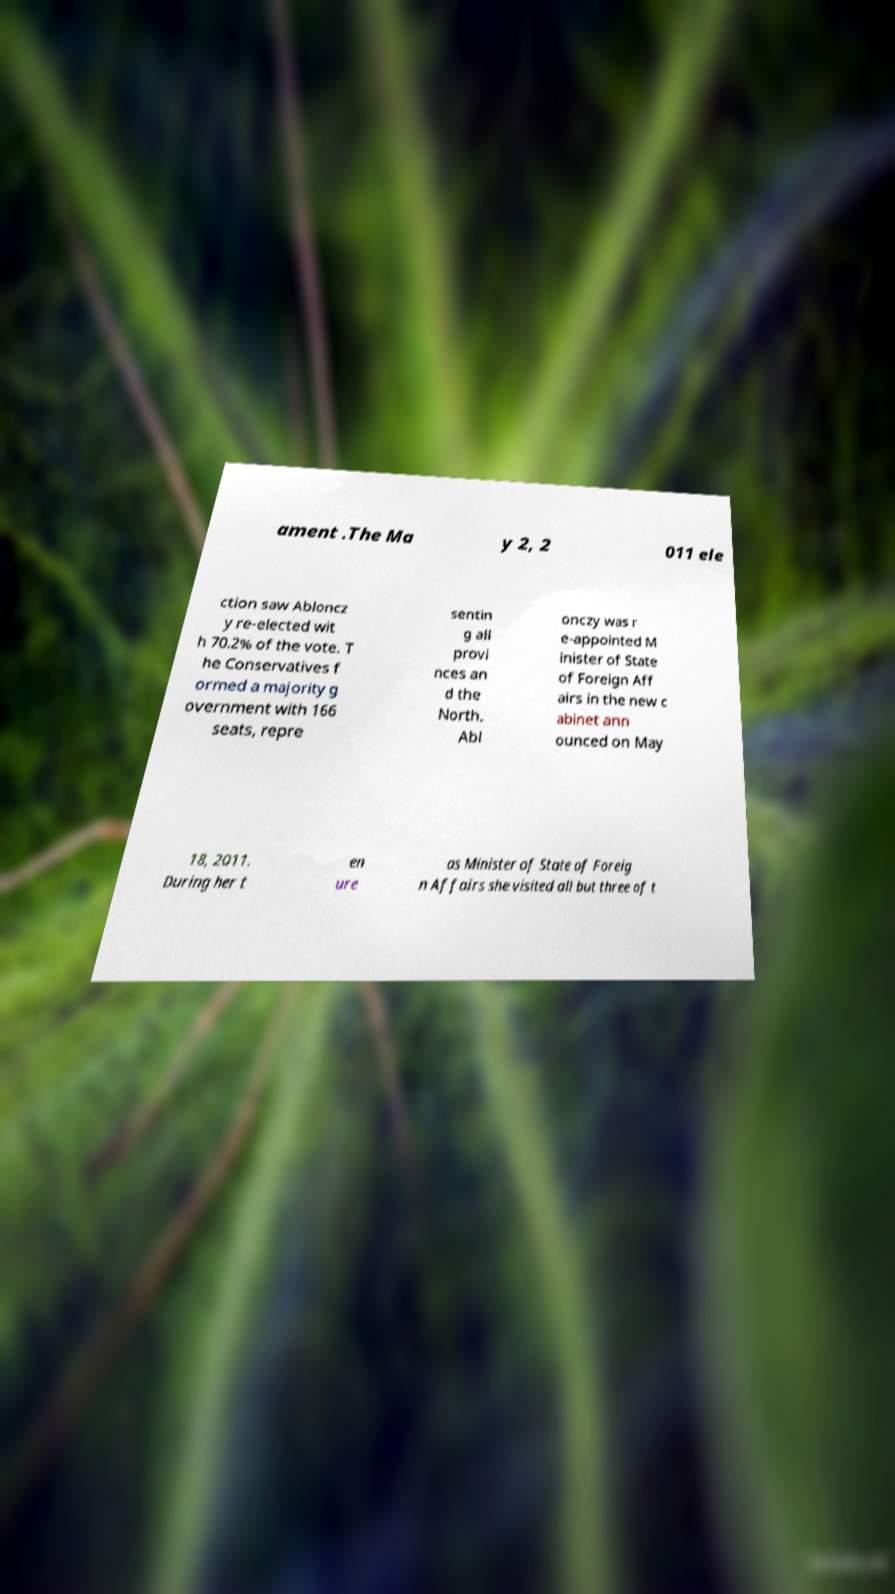Please read and relay the text visible in this image. What does it say? ament .The Ma y 2, 2 011 ele ction saw Abloncz y re-elected wit h 70.2% of the vote. T he Conservatives f ormed a majority g overnment with 166 seats, repre sentin g all provi nces an d the North. Abl onczy was r e-appointed M inister of State of Foreign Aff airs in the new c abinet ann ounced on May 18, 2011. During her t en ure as Minister of State of Foreig n Affairs she visited all but three of t 